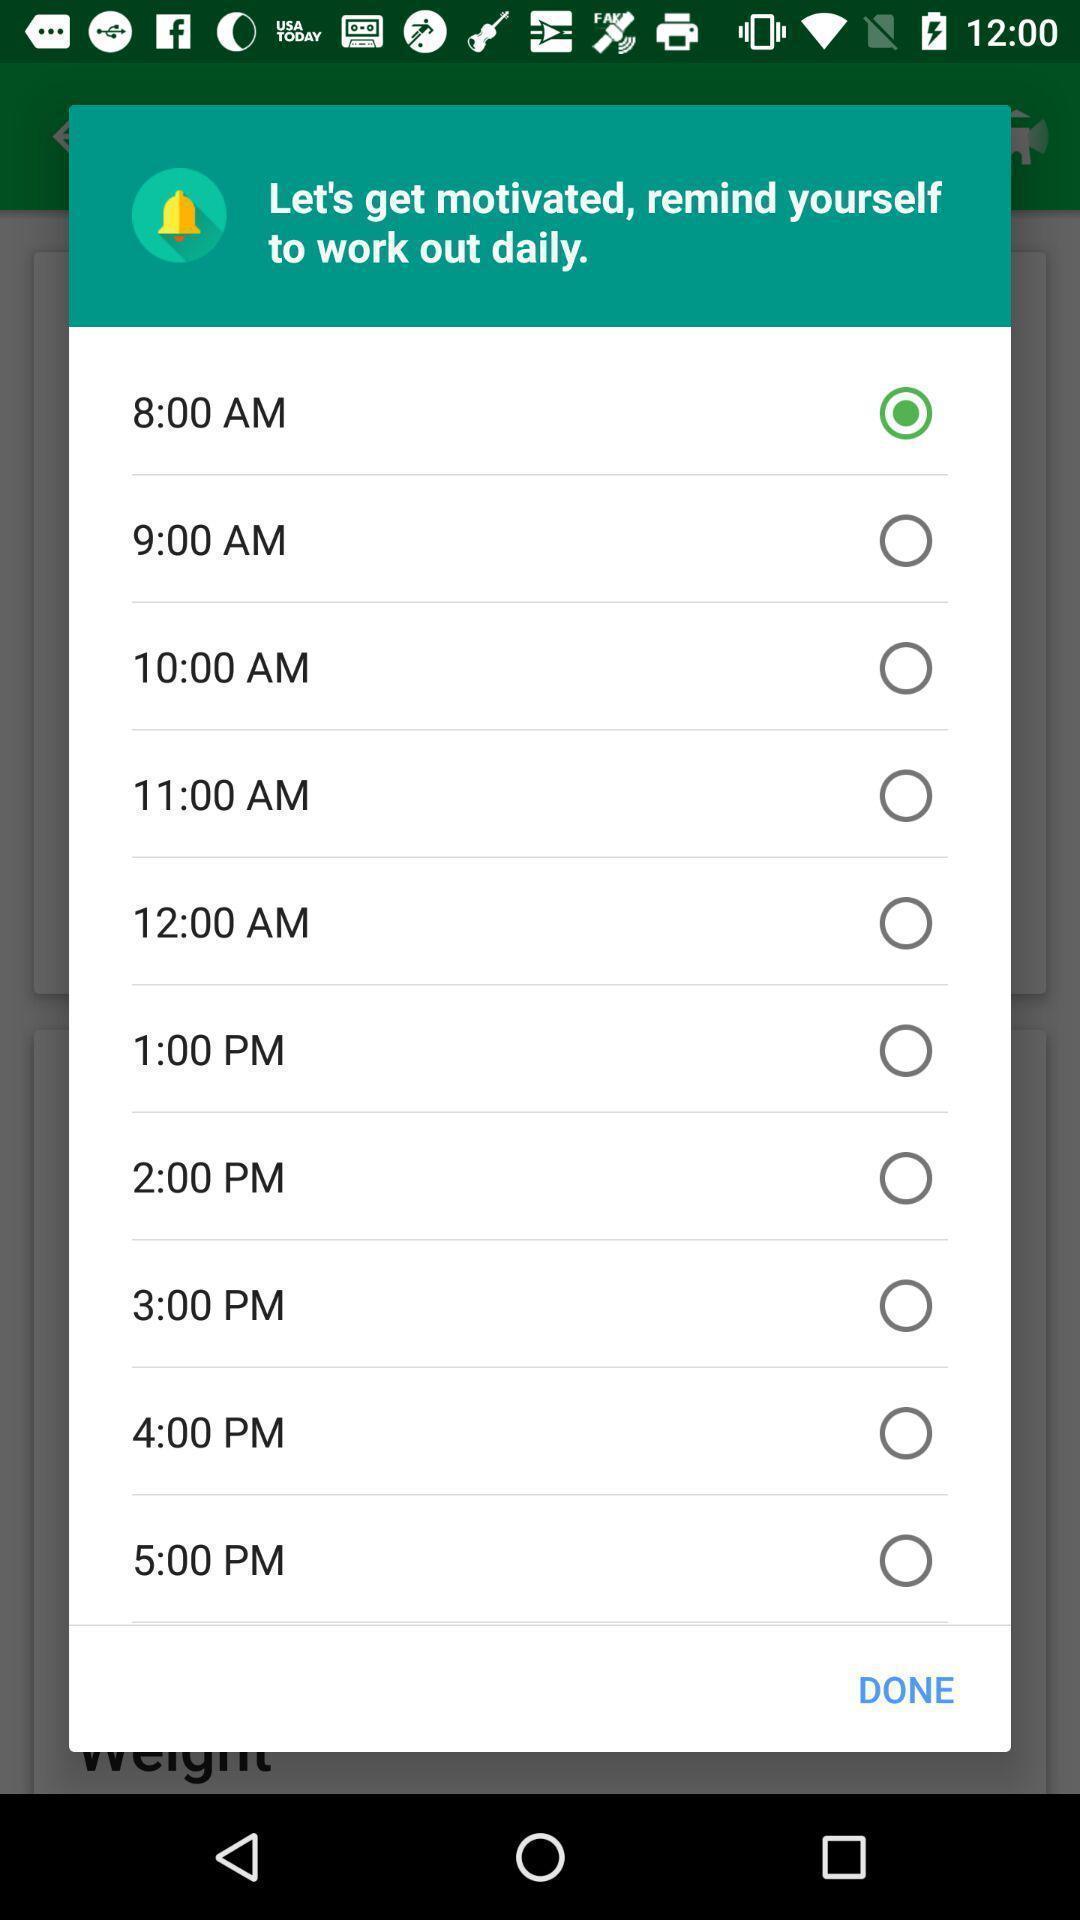Tell me about the visual elements in this screen capture. Pop-up with different timing options to exercise. 